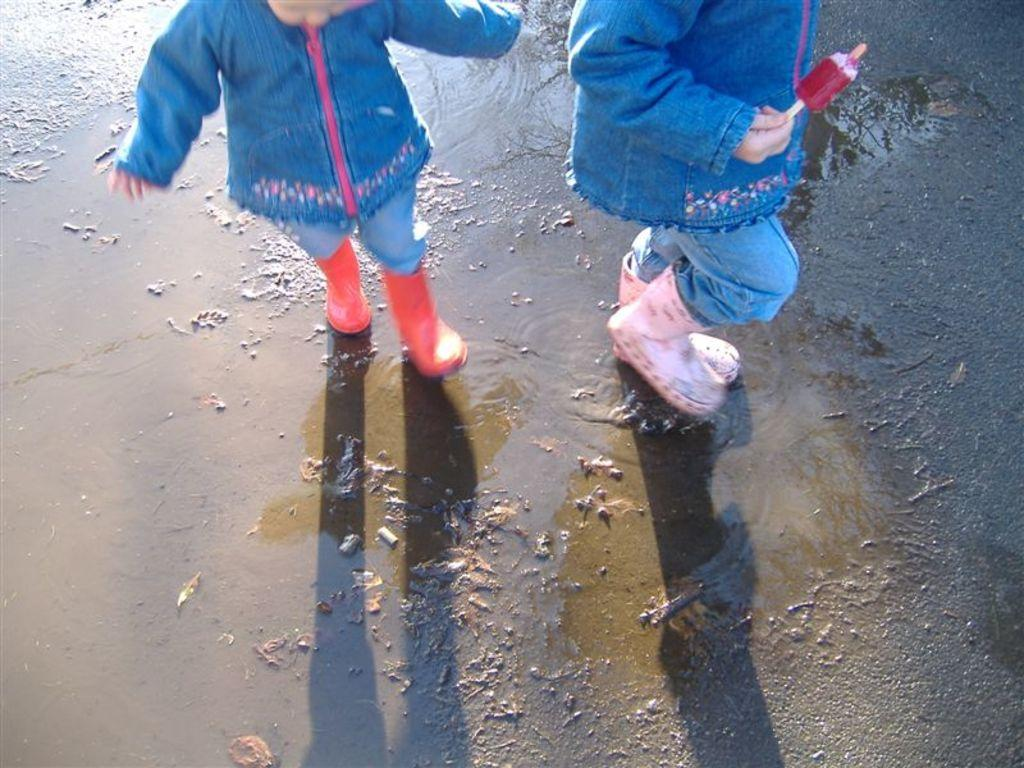How many children are present in the image? There are two children in the image. What is the surface the children are on? The children are on the mud. What is one of the children holding? One of the children is holding an ice cream. What type of screw is the child using to whip the ice cream in the image? There is no screw or whipping action present in the image. The child is simply holding an ice cream. 